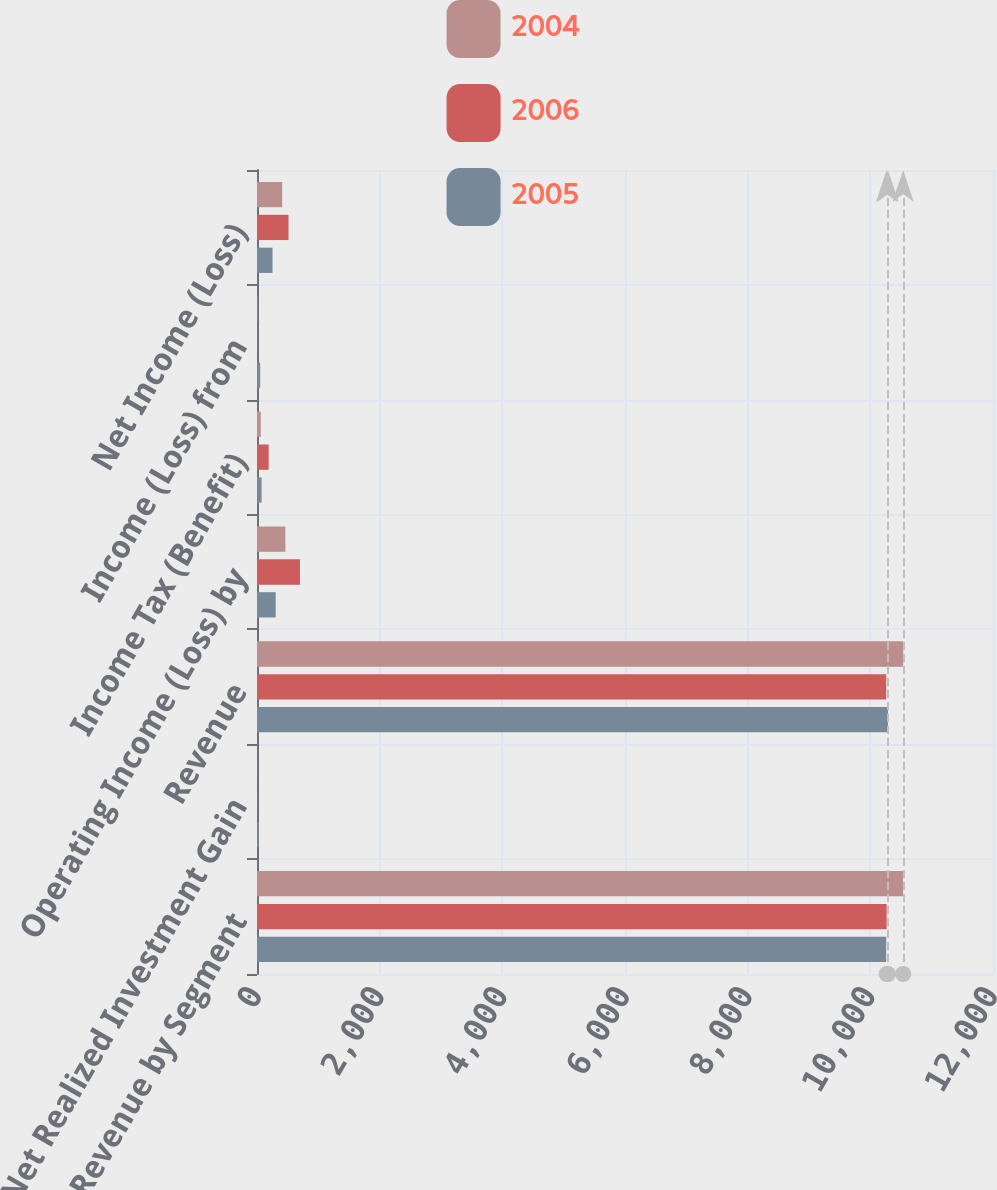<chart> <loc_0><loc_0><loc_500><loc_500><stacked_bar_chart><ecel><fcel>Operating Revenue by Segment<fcel>Net Realized Investment Gain<fcel>Revenue<fcel>Operating Income (Loss) by<fcel>Income Tax (Benefit)<fcel>Income (Loss) from<fcel>Net Income (Loss)<nl><fcel>2004<fcel>10533.1<fcel>2.2<fcel>10535.3<fcel>463.2<fcel>61.8<fcel>7.4<fcel>411<nl><fcel>2006<fcel>10266<fcel>6.7<fcel>10259.3<fcel>700.6<fcel>189.9<fcel>9.6<fcel>513.6<nl><fcel>2005<fcel>10258.6<fcel>29.2<fcel>10287.8<fcel>304.9<fcel>74.3<fcel>51.6<fcel>253<nl></chart> 